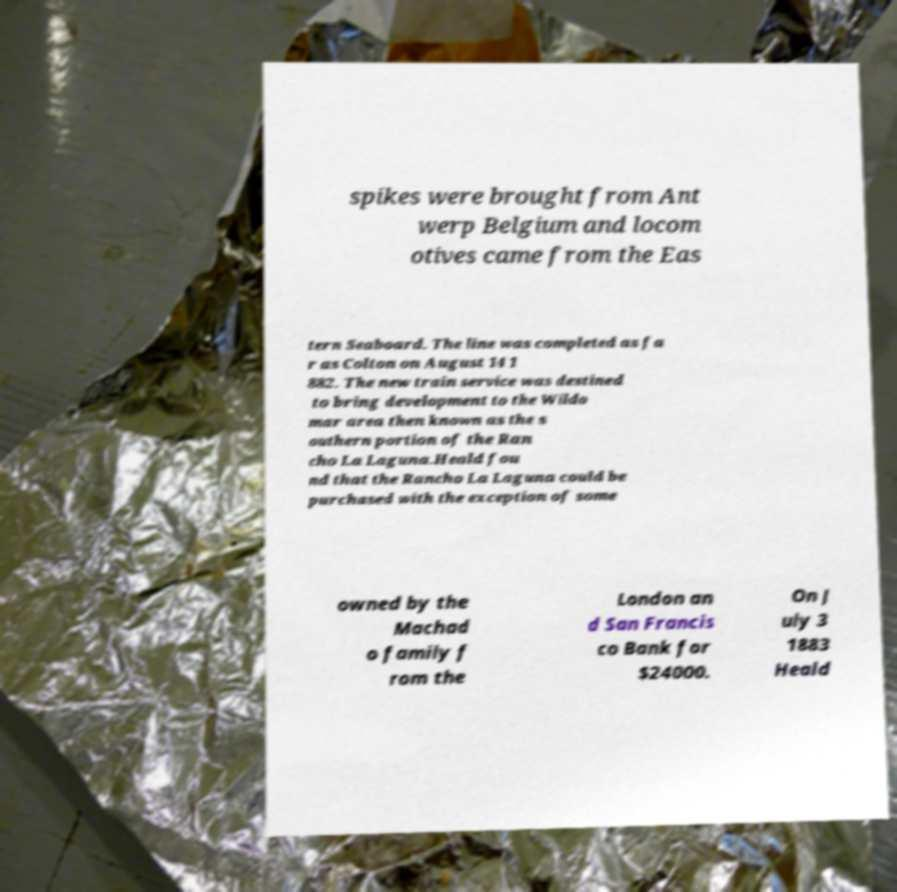There's text embedded in this image that I need extracted. Can you transcribe it verbatim? spikes were brought from Ant werp Belgium and locom otives came from the Eas tern Seaboard. The line was completed as fa r as Colton on August 14 1 882. The new train service was destined to bring development to the Wildo mar area then known as the s outhern portion of the Ran cho La Laguna.Heald fou nd that the Rancho La Laguna could be purchased with the exception of some owned by the Machad o family f rom the London an d San Francis co Bank for $24000. On J uly 3 1883 Heald 